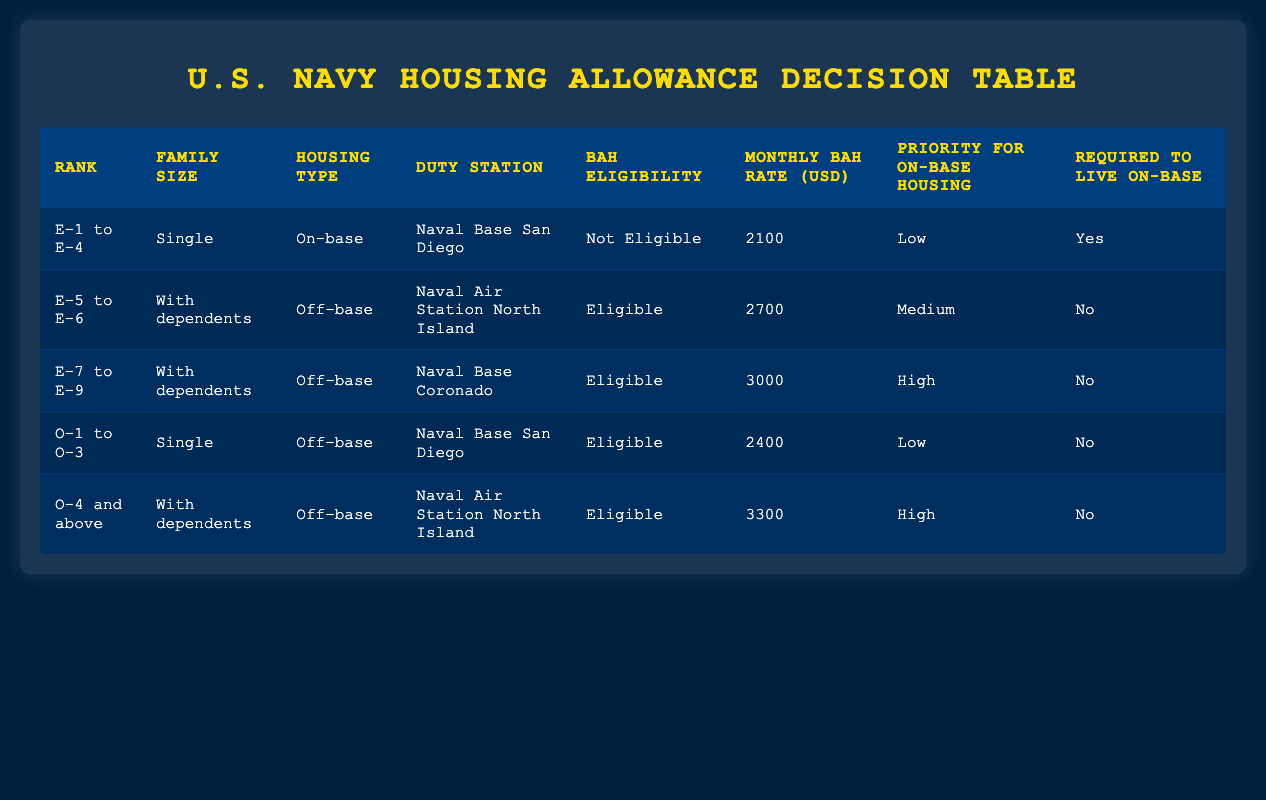What's the BAH eligibility for E-1 to E-4 with dependents? The row for E-1 to E-4 indicates that they are categorized as "Single," and also states "Not Eligible" under BAH eligibility. Therefore, regardless of family size, personnel in this rank and family size category are not eligible for BAH.
Answer: Not Eligible What is the monthly BAH rate for O-4 and above with dependents at Naval Air Station North Island? According to the table, the row for O-4 and above with dependents at Naval Air Station North Island indicates a monthly BAH rate of 3300.
Answer: 3300 Are E-5 to E-6 personnel with dependents eligible for BAH if they're living off-base? In the table, E-5 to E-6 personnel with dependents living off-base at Naval Air Station North Island show they are "Eligible" for BAH.
Answer: Yes What is the priority for on-base housing for E-7 to E-9 with dependents at Naval Base Coronado? The row for E-7 to E-9 with dependents at Naval Base Coronado states "High" under priority for on-base housing, indicating a strong preference for on-base housing eligibility.
Answer: High If an O-1 to O-3 officer is single and living off-base, what is their BAH eligibility? The entry for O-1 to O-3 officers who are single and living off-base at Naval Base San Diego indicates they are "Eligible" for BAH.
Answer: Eligible What is the difference in monthly BAH rate between E-5 to E-6 with dependents and E-7 to E-9 with dependents? The monthly BAH rate for E-5 to E-6 with dependents is 2700, and for E-7 to E-9 with dependents, it is 3000. The difference is calculated as 3000 - 2700 = 300.
Answer: 300 Is a personnel in E-1 to E-4 with dependents required to live on-base? The data for E-1 to E-4 shows "Yes" under required to live on-base. Therefore, they are mandated to reside on-base despite being not eligible for BAH.
Answer: Yes How many ranks are eligible for BAH if they have dependents and are living off-base? Reviewing the table, E-5 to E-6, E-7 to E-9, and O-4 and above, all qualify as eligible for BAH if they have dependents and are living off-base. It totals to three ranks.
Answer: 3 What is the average monthly BAH rate for those eligible for BAH from the table? Eligible rates include 2700 for E-5 to E-6, 3000 for E-7 to E-9, 2400 for O-1 to O-3, and 3300 for O-4 and above. The average is computed as (2700 + 3000 + 2400 + 3300) / 4 = 2850.
Answer: 2850 